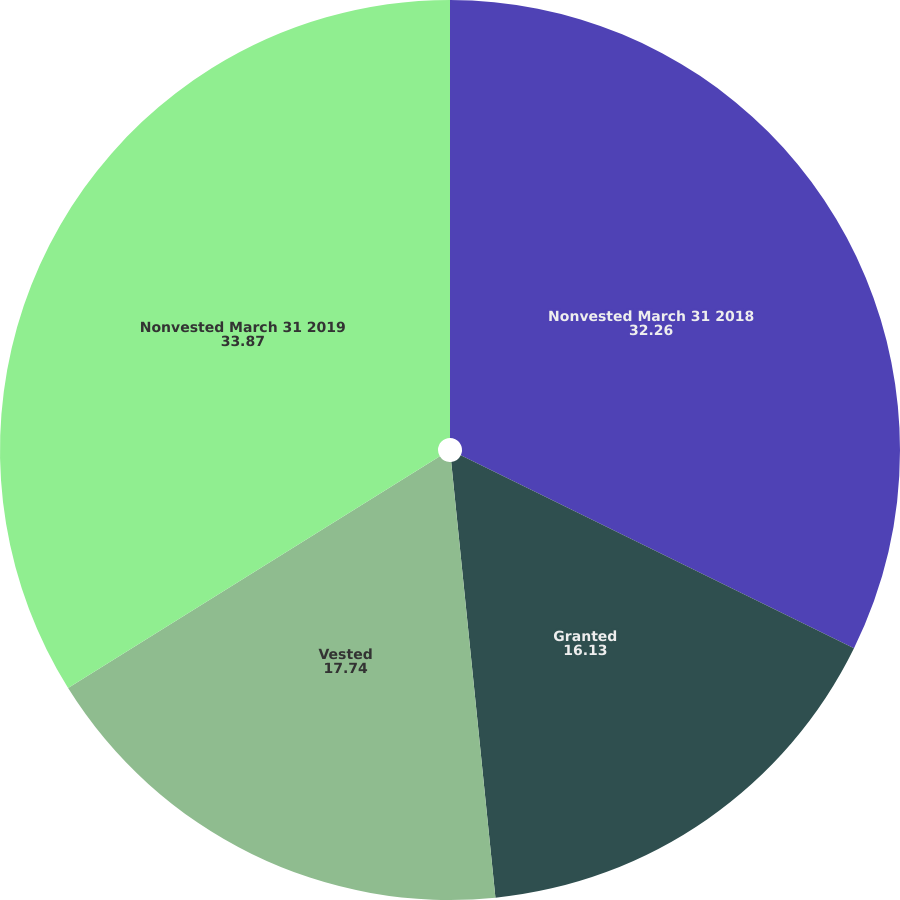<chart> <loc_0><loc_0><loc_500><loc_500><pie_chart><fcel>Nonvested March 31 2018<fcel>Granted<fcel>Vested<fcel>Nonvested March 31 2019<nl><fcel>32.26%<fcel>16.13%<fcel>17.74%<fcel>33.87%<nl></chart> 